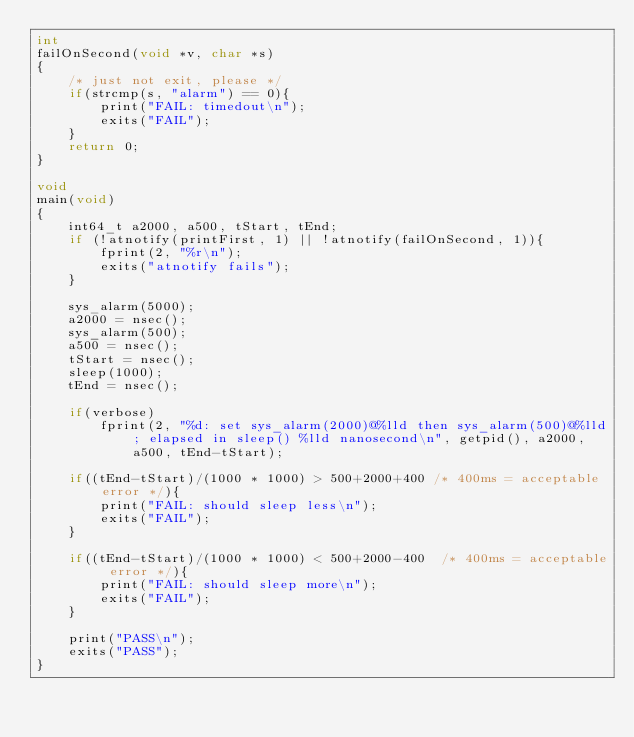Convert code to text. <code><loc_0><loc_0><loc_500><loc_500><_C_>int
failOnSecond(void *v, char *s)
{
	/* just not exit, please */
	if(strcmp(s, "alarm") == 0){
		print("FAIL: timedout\n");
		exits("FAIL");
	}
	return 0;
}

void
main(void)
{
	int64_t a2000, a500, tStart, tEnd;
	if (!atnotify(printFirst, 1) || !atnotify(failOnSecond, 1)){
		fprint(2, "%r\n");
		exits("atnotify fails");
	}

	sys_alarm(5000);
	a2000 = nsec();
	sys_alarm(500);
	a500 = nsec();
	tStart = nsec();
	sleep(1000);
	tEnd = nsec();

	if(verbose)
		fprint(2, "%d: set sys_alarm(2000)@%lld then sys_alarm(500)@%lld; elapsed in sleep() %lld nanosecond\n", getpid(), a2000, a500, tEnd-tStart);

	if((tEnd-tStart)/(1000 * 1000) > 500+2000+400 /* 400ms = acceptable error */){
		print("FAIL: should sleep less\n");
		exits("FAIL");
	}

	if((tEnd-tStart)/(1000 * 1000) < 500+2000-400  /* 400ms = acceptable error */){
		print("FAIL: should sleep more\n");
		exits("FAIL");
	}

	print("PASS\n");
	exits("PASS");
}
</code> 